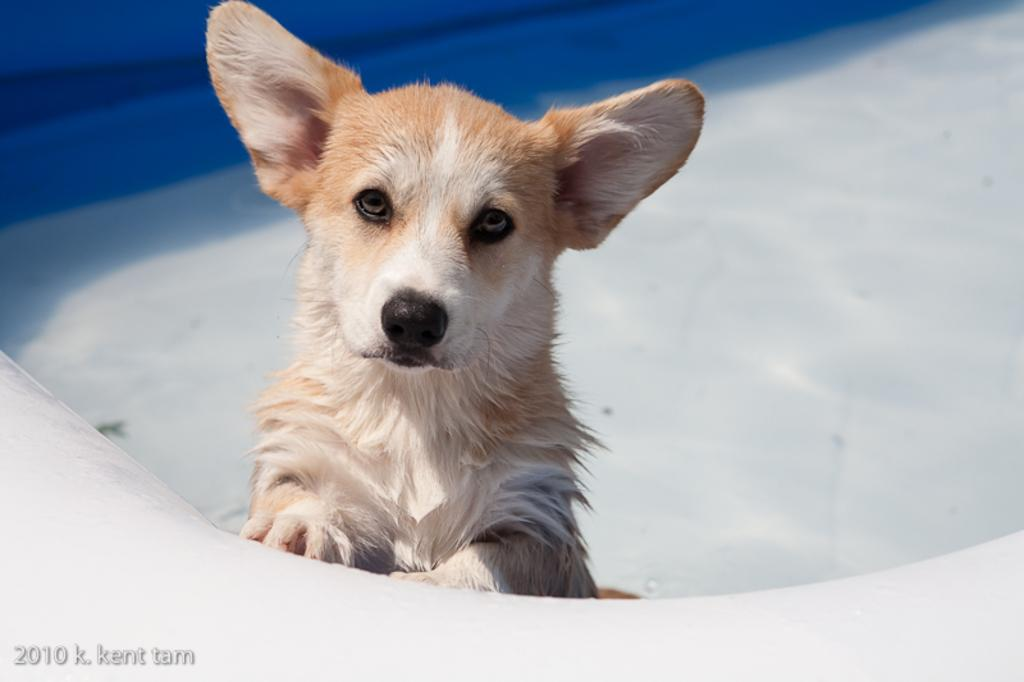What animal is present in the image? There is a dog in the image. What direction is the dog looking in? The dog is looking forward. Is there any text or marking at the bottom of the image? Yes, there is a watermark at the bottom of the image. What colors are used in the background of the image? The background of the image is white and blue. Can you tell me how many women are holding yams in the image? There are no women or yams present in the image; it features a dog looking forward with a watermark at the bottom and a white and blue background. 